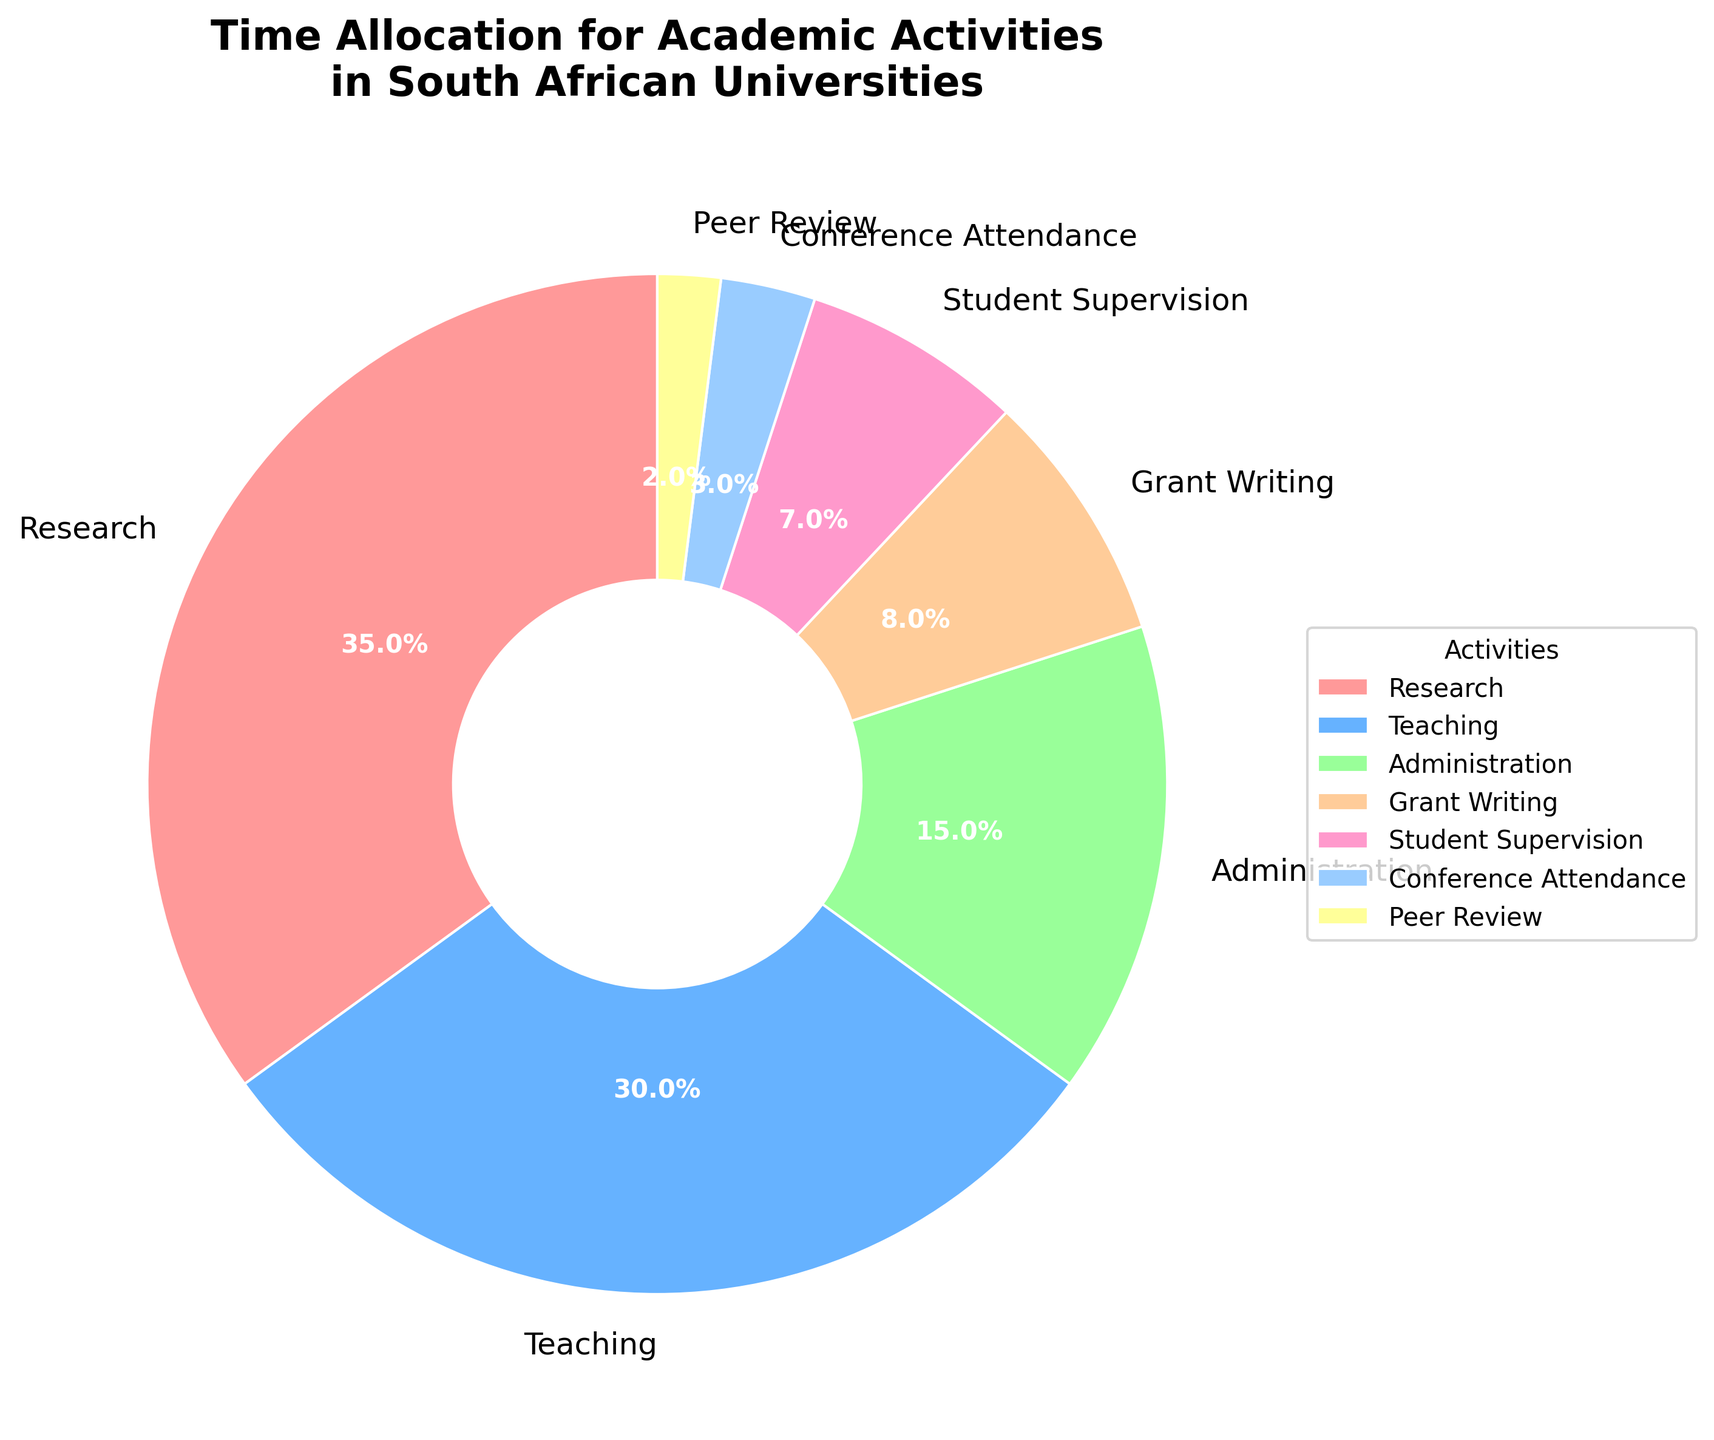What is the most time-consuming academic activity according to the pie chart? The largest slice in the pie chart represents "Research" with 35%, indicating that it's the most time-consuming academic activity.
Answer: Research What is the combined percentage of time spent on Administration and Grant Writing? According to the data, Administration takes 15% of the time and Grant Writing takes 8%. The combined percentage is 15% + 8% = 23%.
Answer: 23% Which activity takes less time: Conference Attendance or Peer Review? The pie chart shows that Conference Attendance takes 3% of the time, while Peer Review takes 2%. Therefore, Peer Review takes less time.
Answer: Peer Review What is the difference in percentage between Teaching and Student Supervision? Teaching takes up 30% of the time and Student Supervision takes 7%. The difference is 30% - 7% = 23%.
Answer: 23% Is the time spent on Administration greater than, less than, or equal to the combined time spent on Conference Attendance and Peer Review? Administration takes 15% of the time. Conference Attendance and Peer Review together take 3% + 2% = 5%. So, Administration takes more time.
Answer: Greater than What percentage of time is allocated to activities other than Research and Teaching? Research and Teaching together take 35% + 30% = 65%. Activities other than these take 100% - 65% = 35%.
Answer: 35% How many activities take up less than 10% of the time each? According to the pie chart, the activities that take up less than 10% are Administration (15%), Grant Writing (8%), Student Supervision (7%), Conference Attendance (3%), and Peer Review (2%). Only Conference Attendance and Peer Review are less than 10%.
Answer: 5 What is the combined percentage of time spent on the three smallest activities? The smallest activities are Conference Attendance (3%), Peer Review (2%), and Student Supervision (7%). The combined percentage is 3% + 2% + 7% = 12%.
Answer: 12% Compare the time spent on Teaching versus the time spent on Peer Review and Grant Writing combined. Which is higher? Teaching takes 30% of the time. Peer Review and Grant Writing together take 2% + 8% = 10%. Therefore, more time is spent on Teaching.
Answer: Teaching 